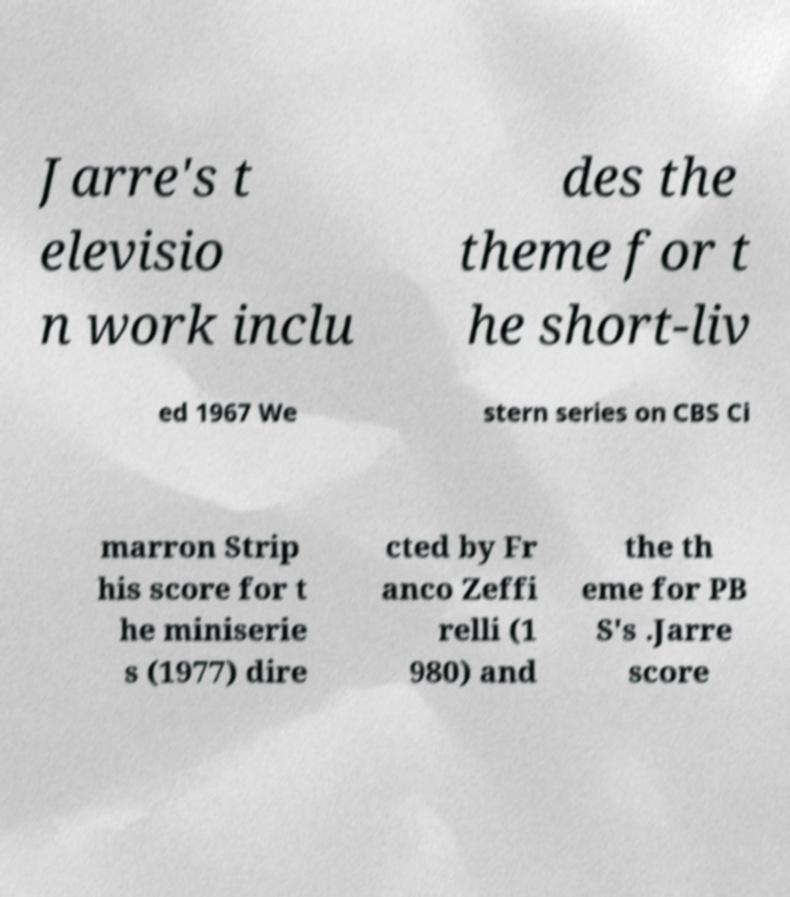Please read and relay the text visible in this image. What does it say? Jarre's t elevisio n work inclu des the theme for t he short-liv ed 1967 We stern series on CBS Ci marron Strip his score for t he miniserie s (1977) dire cted by Fr anco Zeffi relli (1 980) and the th eme for PB S's .Jarre score 